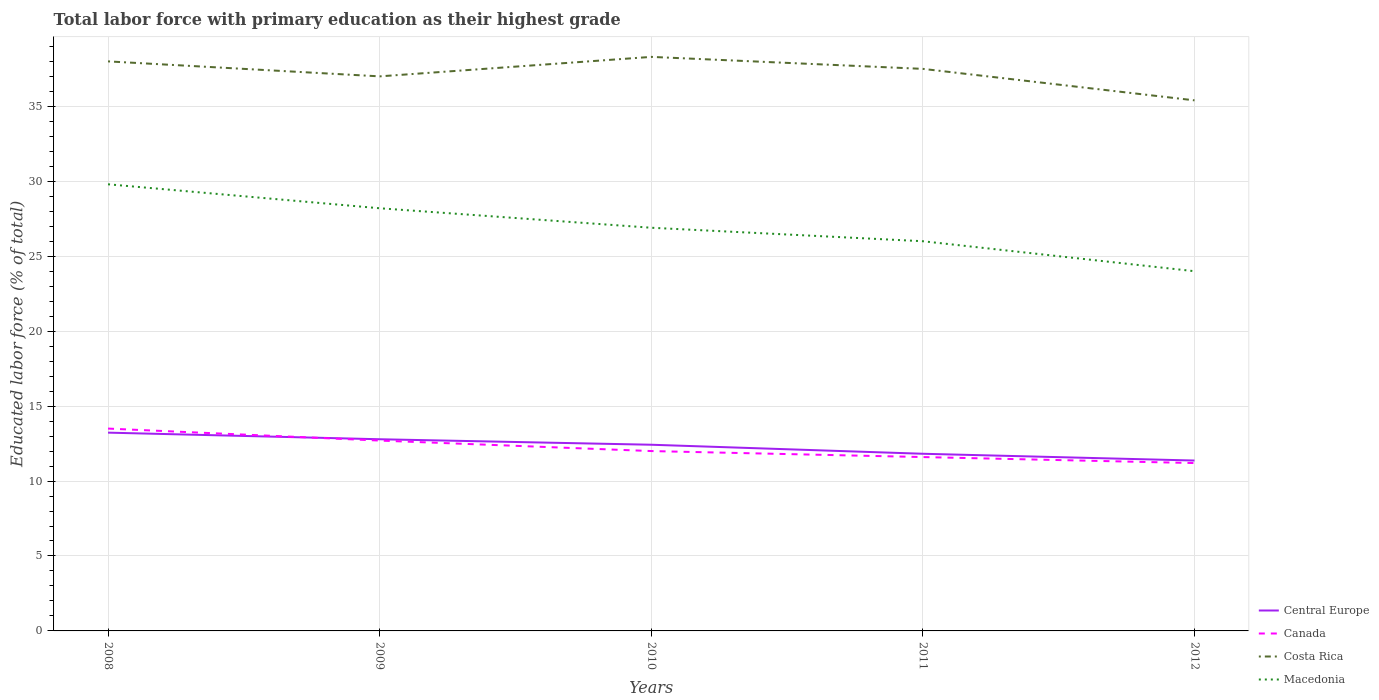How many different coloured lines are there?
Offer a terse response. 4. Does the line corresponding to Canada intersect with the line corresponding to Macedonia?
Make the answer very short. No. Across all years, what is the maximum percentage of total labor force with primary education in Canada?
Your answer should be very brief. 11.2. What is the total percentage of total labor force with primary education in Canada in the graph?
Give a very brief answer. 1.1. What is the difference between the highest and the second highest percentage of total labor force with primary education in Central Europe?
Provide a succinct answer. 1.86. What is the difference between the highest and the lowest percentage of total labor force with primary education in Macedonia?
Give a very brief answer. 2. What is the difference between two consecutive major ticks on the Y-axis?
Provide a succinct answer. 5. Are the values on the major ticks of Y-axis written in scientific E-notation?
Provide a short and direct response. No. Where does the legend appear in the graph?
Make the answer very short. Bottom right. How many legend labels are there?
Provide a short and direct response. 4. How are the legend labels stacked?
Keep it short and to the point. Vertical. What is the title of the graph?
Offer a very short reply. Total labor force with primary education as their highest grade. What is the label or title of the X-axis?
Offer a very short reply. Years. What is the label or title of the Y-axis?
Your answer should be compact. Educated labor force (% of total). What is the Educated labor force (% of total) in Central Europe in 2008?
Provide a short and direct response. 13.23. What is the Educated labor force (% of total) of Macedonia in 2008?
Offer a very short reply. 29.8. What is the Educated labor force (% of total) of Central Europe in 2009?
Make the answer very short. 12.79. What is the Educated labor force (% of total) in Canada in 2009?
Keep it short and to the point. 12.7. What is the Educated labor force (% of total) in Macedonia in 2009?
Give a very brief answer. 28.2. What is the Educated labor force (% of total) in Central Europe in 2010?
Make the answer very short. 12.42. What is the Educated labor force (% of total) of Costa Rica in 2010?
Your answer should be compact. 38.3. What is the Educated labor force (% of total) in Macedonia in 2010?
Offer a very short reply. 26.9. What is the Educated labor force (% of total) of Central Europe in 2011?
Make the answer very short. 11.82. What is the Educated labor force (% of total) of Canada in 2011?
Your answer should be very brief. 11.6. What is the Educated labor force (% of total) in Costa Rica in 2011?
Your answer should be compact. 37.5. What is the Educated labor force (% of total) in Central Europe in 2012?
Provide a short and direct response. 11.37. What is the Educated labor force (% of total) in Canada in 2012?
Your response must be concise. 11.2. What is the Educated labor force (% of total) of Costa Rica in 2012?
Give a very brief answer. 35.4. Across all years, what is the maximum Educated labor force (% of total) of Central Europe?
Provide a short and direct response. 13.23. Across all years, what is the maximum Educated labor force (% of total) in Costa Rica?
Provide a short and direct response. 38.3. Across all years, what is the maximum Educated labor force (% of total) in Macedonia?
Provide a short and direct response. 29.8. Across all years, what is the minimum Educated labor force (% of total) in Central Europe?
Provide a succinct answer. 11.37. Across all years, what is the minimum Educated labor force (% of total) in Canada?
Provide a succinct answer. 11.2. Across all years, what is the minimum Educated labor force (% of total) of Costa Rica?
Give a very brief answer. 35.4. Across all years, what is the minimum Educated labor force (% of total) of Macedonia?
Your response must be concise. 24. What is the total Educated labor force (% of total) of Central Europe in the graph?
Your answer should be very brief. 61.63. What is the total Educated labor force (% of total) of Costa Rica in the graph?
Provide a succinct answer. 186.2. What is the total Educated labor force (% of total) of Macedonia in the graph?
Keep it short and to the point. 134.9. What is the difference between the Educated labor force (% of total) in Central Europe in 2008 and that in 2009?
Your response must be concise. 0.44. What is the difference between the Educated labor force (% of total) of Canada in 2008 and that in 2009?
Offer a terse response. 0.8. What is the difference between the Educated labor force (% of total) in Macedonia in 2008 and that in 2009?
Your answer should be compact. 1.6. What is the difference between the Educated labor force (% of total) in Central Europe in 2008 and that in 2010?
Offer a very short reply. 0.81. What is the difference between the Educated labor force (% of total) of Canada in 2008 and that in 2010?
Your answer should be compact. 1.5. What is the difference between the Educated labor force (% of total) of Macedonia in 2008 and that in 2010?
Your response must be concise. 2.9. What is the difference between the Educated labor force (% of total) of Central Europe in 2008 and that in 2011?
Give a very brief answer. 1.41. What is the difference between the Educated labor force (% of total) in Costa Rica in 2008 and that in 2011?
Offer a terse response. 0.5. What is the difference between the Educated labor force (% of total) in Central Europe in 2008 and that in 2012?
Your answer should be very brief. 1.86. What is the difference between the Educated labor force (% of total) of Canada in 2008 and that in 2012?
Give a very brief answer. 2.3. What is the difference between the Educated labor force (% of total) in Costa Rica in 2008 and that in 2012?
Your answer should be very brief. 2.6. What is the difference between the Educated labor force (% of total) of Central Europe in 2009 and that in 2010?
Your answer should be very brief. 0.37. What is the difference between the Educated labor force (% of total) in Macedonia in 2009 and that in 2010?
Offer a terse response. 1.3. What is the difference between the Educated labor force (% of total) in Central Europe in 2009 and that in 2011?
Provide a succinct answer. 0.97. What is the difference between the Educated labor force (% of total) in Canada in 2009 and that in 2011?
Make the answer very short. 1.1. What is the difference between the Educated labor force (% of total) of Central Europe in 2009 and that in 2012?
Ensure brevity in your answer.  1.42. What is the difference between the Educated labor force (% of total) in Canada in 2009 and that in 2012?
Your answer should be very brief. 1.5. What is the difference between the Educated labor force (% of total) of Costa Rica in 2009 and that in 2012?
Give a very brief answer. 1.6. What is the difference between the Educated labor force (% of total) in Macedonia in 2009 and that in 2012?
Provide a short and direct response. 4.2. What is the difference between the Educated labor force (% of total) in Central Europe in 2010 and that in 2011?
Keep it short and to the point. 0.6. What is the difference between the Educated labor force (% of total) in Costa Rica in 2010 and that in 2011?
Offer a very short reply. 0.8. What is the difference between the Educated labor force (% of total) in Central Europe in 2010 and that in 2012?
Keep it short and to the point. 1.05. What is the difference between the Educated labor force (% of total) of Canada in 2010 and that in 2012?
Offer a terse response. 0.8. What is the difference between the Educated labor force (% of total) in Macedonia in 2010 and that in 2012?
Make the answer very short. 2.9. What is the difference between the Educated labor force (% of total) in Central Europe in 2011 and that in 2012?
Your response must be concise. 0.45. What is the difference between the Educated labor force (% of total) in Canada in 2011 and that in 2012?
Your answer should be compact. 0.4. What is the difference between the Educated labor force (% of total) in Central Europe in 2008 and the Educated labor force (% of total) in Canada in 2009?
Give a very brief answer. 0.53. What is the difference between the Educated labor force (% of total) in Central Europe in 2008 and the Educated labor force (% of total) in Costa Rica in 2009?
Your response must be concise. -23.77. What is the difference between the Educated labor force (% of total) in Central Europe in 2008 and the Educated labor force (% of total) in Macedonia in 2009?
Your answer should be compact. -14.97. What is the difference between the Educated labor force (% of total) of Canada in 2008 and the Educated labor force (% of total) of Costa Rica in 2009?
Ensure brevity in your answer.  -23.5. What is the difference between the Educated labor force (% of total) in Canada in 2008 and the Educated labor force (% of total) in Macedonia in 2009?
Your answer should be compact. -14.7. What is the difference between the Educated labor force (% of total) in Costa Rica in 2008 and the Educated labor force (% of total) in Macedonia in 2009?
Your response must be concise. 9.8. What is the difference between the Educated labor force (% of total) of Central Europe in 2008 and the Educated labor force (% of total) of Canada in 2010?
Offer a terse response. 1.23. What is the difference between the Educated labor force (% of total) in Central Europe in 2008 and the Educated labor force (% of total) in Costa Rica in 2010?
Your answer should be very brief. -25.07. What is the difference between the Educated labor force (% of total) of Central Europe in 2008 and the Educated labor force (% of total) of Macedonia in 2010?
Offer a very short reply. -13.67. What is the difference between the Educated labor force (% of total) of Canada in 2008 and the Educated labor force (% of total) of Costa Rica in 2010?
Your answer should be compact. -24.8. What is the difference between the Educated labor force (% of total) of Costa Rica in 2008 and the Educated labor force (% of total) of Macedonia in 2010?
Your answer should be very brief. 11.1. What is the difference between the Educated labor force (% of total) of Central Europe in 2008 and the Educated labor force (% of total) of Canada in 2011?
Your answer should be compact. 1.63. What is the difference between the Educated labor force (% of total) of Central Europe in 2008 and the Educated labor force (% of total) of Costa Rica in 2011?
Ensure brevity in your answer.  -24.27. What is the difference between the Educated labor force (% of total) of Central Europe in 2008 and the Educated labor force (% of total) of Macedonia in 2011?
Provide a succinct answer. -12.77. What is the difference between the Educated labor force (% of total) in Canada in 2008 and the Educated labor force (% of total) in Costa Rica in 2011?
Ensure brevity in your answer.  -24. What is the difference between the Educated labor force (% of total) of Canada in 2008 and the Educated labor force (% of total) of Macedonia in 2011?
Make the answer very short. -12.5. What is the difference between the Educated labor force (% of total) in Central Europe in 2008 and the Educated labor force (% of total) in Canada in 2012?
Provide a succinct answer. 2.03. What is the difference between the Educated labor force (% of total) in Central Europe in 2008 and the Educated labor force (% of total) in Costa Rica in 2012?
Your answer should be compact. -22.17. What is the difference between the Educated labor force (% of total) in Central Europe in 2008 and the Educated labor force (% of total) in Macedonia in 2012?
Ensure brevity in your answer.  -10.77. What is the difference between the Educated labor force (% of total) in Canada in 2008 and the Educated labor force (% of total) in Costa Rica in 2012?
Make the answer very short. -21.9. What is the difference between the Educated labor force (% of total) in Canada in 2008 and the Educated labor force (% of total) in Macedonia in 2012?
Make the answer very short. -10.5. What is the difference between the Educated labor force (% of total) of Central Europe in 2009 and the Educated labor force (% of total) of Canada in 2010?
Provide a short and direct response. 0.79. What is the difference between the Educated labor force (% of total) in Central Europe in 2009 and the Educated labor force (% of total) in Costa Rica in 2010?
Your answer should be compact. -25.51. What is the difference between the Educated labor force (% of total) in Central Europe in 2009 and the Educated labor force (% of total) in Macedonia in 2010?
Provide a short and direct response. -14.11. What is the difference between the Educated labor force (% of total) in Canada in 2009 and the Educated labor force (% of total) in Costa Rica in 2010?
Provide a succinct answer. -25.6. What is the difference between the Educated labor force (% of total) in Central Europe in 2009 and the Educated labor force (% of total) in Canada in 2011?
Your answer should be compact. 1.19. What is the difference between the Educated labor force (% of total) in Central Europe in 2009 and the Educated labor force (% of total) in Costa Rica in 2011?
Keep it short and to the point. -24.71. What is the difference between the Educated labor force (% of total) in Central Europe in 2009 and the Educated labor force (% of total) in Macedonia in 2011?
Provide a short and direct response. -13.21. What is the difference between the Educated labor force (% of total) in Canada in 2009 and the Educated labor force (% of total) in Costa Rica in 2011?
Offer a terse response. -24.8. What is the difference between the Educated labor force (% of total) of Central Europe in 2009 and the Educated labor force (% of total) of Canada in 2012?
Your answer should be very brief. 1.59. What is the difference between the Educated labor force (% of total) in Central Europe in 2009 and the Educated labor force (% of total) in Costa Rica in 2012?
Provide a short and direct response. -22.61. What is the difference between the Educated labor force (% of total) in Central Europe in 2009 and the Educated labor force (% of total) in Macedonia in 2012?
Provide a short and direct response. -11.21. What is the difference between the Educated labor force (% of total) in Canada in 2009 and the Educated labor force (% of total) in Costa Rica in 2012?
Your response must be concise. -22.7. What is the difference between the Educated labor force (% of total) in Canada in 2009 and the Educated labor force (% of total) in Macedonia in 2012?
Your answer should be very brief. -11.3. What is the difference between the Educated labor force (% of total) of Costa Rica in 2009 and the Educated labor force (% of total) of Macedonia in 2012?
Your answer should be very brief. 13. What is the difference between the Educated labor force (% of total) in Central Europe in 2010 and the Educated labor force (% of total) in Canada in 2011?
Ensure brevity in your answer.  0.82. What is the difference between the Educated labor force (% of total) of Central Europe in 2010 and the Educated labor force (% of total) of Costa Rica in 2011?
Your answer should be very brief. -25.08. What is the difference between the Educated labor force (% of total) in Central Europe in 2010 and the Educated labor force (% of total) in Macedonia in 2011?
Offer a terse response. -13.58. What is the difference between the Educated labor force (% of total) in Canada in 2010 and the Educated labor force (% of total) in Costa Rica in 2011?
Your response must be concise. -25.5. What is the difference between the Educated labor force (% of total) in Canada in 2010 and the Educated labor force (% of total) in Macedonia in 2011?
Keep it short and to the point. -14. What is the difference between the Educated labor force (% of total) in Costa Rica in 2010 and the Educated labor force (% of total) in Macedonia in 2011?
Make the answer very short. 12.3. What is the difference between the Educated labor force (% of total) in Central Europe in 2010 and the Educated labor force (% of total) in Canada in 2012?
Provide a short and direct response. 1.22. What is the difference between the Educated labor force (% of total) of Central Europe in 2010 and the Educated labor force (% of total) of Costa Rica in 2012?
Give a very brief answer. -22.98. What is the difference between the Educated labor force (% of total) of Central Europe in 2010 and the Educated labor force (% of total) of Macedonia in 2012?
Your response must be concise. -11.58. What is the difference between the Educated labor force (% of total) in Canada in 2010 and the Educated labor force (% of total) in Costa Rica in 2012?
Offer a very short reply. -23.4. What is the difference between the Educated labor force (% of total) in Costa Rica in 2010 and the Educated labor force (% of total) in Macedonia in 2012?
Your answer should be very brief. 14.3. What is the difference between the Educated labor force (% of total) of Central Europe in 2011 and the Educated labor force (% of total) of Canada in 2012?
Make the answer very short. 0.62. What is the difference between the Educated labor force (% of total) in Central Europe in 2011 and the Educated labor force (% of total) in Costa Rica in 2012?
Your answer should be compact. -23.58. What is the difference between the Educated labor force (% of total) in Central Europe in 2011 and the Educated labor force (% of total) in Macedonia in 2012?
Keep it short and to the point. -12.18. What is the difference between the Educated labor force (% of total) of Canada in 2011 and the Educated labor force (% of total) of Costa Rica in 2012?
Ensure brevity in your answer.  -23.8. What is the difference between the Educated labor force (% of total) of Canada in 2011 and the Educated labor force (% of total) of Macedonia in 2012?
Make the answer very short. -12.4. What is the average Educated labor force (% of total) in Central Europe per year?
Your answer should be compact. 12.33. What is the average Educated labor force (% of total) of Canada per year?
Offer a terse response. 12.2. What is the average Educated labor force (% of total) in Costa Rica per year?
Your answer should be very brief. 37.24. What is the average Educated labor force (% of total) of Macedonia per year?
Give a very brief answer. 26.98. In the year 2008, what is the difference between the Educated labor force (% of total) in Central Europe and Educated labor force (% of total) in Canada?
Provide a short and direct response. -0.27. In the year 2008, what is the difference between the Educated labor force (% of total) in Central Europe and Educated labor force (% of total) in Costa Rica?
Keep it short and to the point. -24.77. In the year 2008, what is the difference between the Educated labor force (% of total) of Central Europe and Educated labor force (% of total) of Macedonia?
Offer a very short reply. -16.57. In the year 2008, what is the difference between the Educated labor force (% of total) in Canada and Educated labor force (% of total) in Costa Rica?
Offer a terse response. -24.5. In the year 2008, what is the difference between the Educated labor force (% of total) in Canada and Educated labor force (% of total) in Macedonia?
Give a very brief answer. -16.3. In the year 2009, what is the difference between the Educated labor force (% of total) of Central Europe and Educated labor force (% of total) of Canada?
Your answer should be very brief. 0.09. In the year 2009, what is the difference between the Educated labor force (% of total) in Central Europe and Educated labor force (% of total) in Costa Rica?
Provide a short and direct response. -24.21. In the year 2009, what is the difference between the Educated labor force (% of total) in Central Europe and Educated labor force (% of total) in Macedonia?
Offer a terse response. -15.41. In the year 2009, what is the difference between the Educated labor force (% of total) of Canada and Educated labor force (% of total) of Costa Rica?
Your response must be concise. -24.3. In the year 2009, what is the difference between the Educated labor force (% of total) in Canada and Educated labor force (% of total) in Macedonia?
Your response must be concise. -15.5. In the year 2010, what is the difference between the Educated labor force (% of total) of Central Europe and Educated labor force (% of total) of Canada?
Your answer should be very brief. 0.42. In the year 2010, what is the difference between the Educated labor force (% of total) of Central Europe and Educated labor force (% of total) of Costa Rica?
Give a very brief answer. -25.88. In the year 2010, what is the difference between the Educated labor force (% of total) in Central Europe and Educated labor force (% of total) in Macedonia?
Keep it short and to the point. -14.48. In the year 2010, what is the difference between the Educated labor force (% of total) of Canada and Educated labor force (% of total) of Costa Rica?
Provide a short and direct response. -26.3. In the year 2010, what is the difference between the Educated labor force (% of total) of Canada and Educated labor force (% of total) of Macedonia?
Your response must be concise. -14.9. In the year 2011, what is the difference between the Educated labor force (% of total) in Central Europe and Educated labor force (% of total) in Canada?
Your response must be concise. 0.22. In the year 2011, what is the difference between the Educated labor force (% of total) of Central Europe and Educated labor force (% of total) of Costa Rica?
Provide a succinct answer. -25.68. In the year 2011, what is the difference between the Educated labor force (% of total) of Central Europe and Educated labor force (% of total) of Macedonia?
Offer a terse response. -14.18. In the year 2011, what is the difference between the Educated labor force (% of total) of Canada and Educated labor force (% of total) of Costa Rica?
Provide a short and direct response. -25.9. In the year 2011, what is the difference between the Educated labor force (% of total) in Canada and Educated labor force (% of total) in Macedonia?
Offer a terse response. -14.4. In the year 2011, what is the difference between the Educated labor force (% of total) of Costa Rica and Educated labor force (% of total) of Macedonia?
Offer a terse response. 11.5. In the year 2012, what is the difference between the Educated labor force (% of total) in Central Europe and Educated labor force (% of total) in Canada?
Provide a succinct answer. 0.17. In the year 2012, what is the difference between the Educated labor force (% of total) of Central Europe and Educated labor force (% of total) of Costa Rica?
Provide a succinct answer. -24.03. In the year 2012, what is the difference between the Educated labor force (% of total) of Central Europe and Educated labor force (% of total) of Macedonia?
Ensure brevity in your answer.  -12.63. In the year 2012, what is the difference between the Educated labor force (% of total) in Canada and Educated labor force (% of total) in Costa Rica?
Provide a short and direct response. -24.2. What is the ratio of the Educated labor force (% of total) in Central Europe in 2008 to that in 2009?
Your response must be concise. 1.03. What is the ratio of the Educated labor force (% of total) in Canada in 2008 to that in 2009?
Your response must be concise. 1.06. What is the ratio of the Educated labor force (% of total) of Macedonia in 2008 to that in 2009?
Offer a terse response. 1.06. What is the ratio of the Educated labor force (% of total) in Central Europe in 2008 to that in 2010?
Offer a very short reply. 1.06. What is the ratio of the Educated labor force (% of total) in Macedonia in 2008 to that in 2010?
Your answer should be compact. 1.11. What is the ratio of the Educated labor force (% of total) of Central Europe in 2008 to that in 2011?
Offer a very short reply. 1.12. What is the ratio of the Educated labor force (% of total) in Canada in 2008 to that in 2011?
Your answer should be compact. 1.16. What is the ratio of the Educated labor force (% of total) of Costa Rica in 2008 to that in 2011?
Offer a terse response. 1.01. What is the ratio of the Educated labor force (% of total) in Macedonia in 2008 to that in 2011?
Ensure brevity in your answer.  1.15. What is the ratio of the Educated labor force (% of total) in Central Europe in 2008 to that in 2012?
Provide a short and direct response. 1.16. What is the ratio of the Educated labor force (% of total) in Canada in 2008 to that in 2012?
Make the answer very short. 1.21. What is the ratio of the Educated labor force (% of total) in Costa Rica in 2008 to that in 2012?
Make the answer very short. 1.07. What is the ratio of the Educated labor force (% of total) of Macedonia in 2008 to that in 2012?
Provide a succinct answer. 1.24. What is the ratio of the Educated labor force (% of total) of Central Europe in 2009 to that in 2010?
Provide a succinct answer. 1.03. What is the ratio of the Educated labor force (% of total) in Canada in 2009 to that in 2010?
Ensure brevity in your answer.  1.06. What is the ratio of the Educated labor force (% of total) in Costa Rica in 2009 to that in 2010?
Make the answer very short. 0.97. What is the ratio of the Educated labor force (% of total) in Macedonia in 2009 to that in 2010?
Your answer should be compact. 1.05. What is the ratio of the Educated labor force (% of total) in Central Europe in 2009 to that in 2011?
Make the answer very short. 1.08. What is the ratio of the Educated labor force (% of total) of Canada in 2009 to that in 2011?
Your answer should be very brief. 1.09. What is the ratio of the Educated labor force (% of total) of Costa Rica in 2009 to that in 2011?
Your answer should be very brief. 0.99. What is the ratio of the Educated labor force (% of total) in Macedonia in 2009 to that in 2011?
Offer a terse response. 1.08. What is the ratio of the Educated labor force (% of total) in Canada in 2009 to that in 2012?
Provide a short and direct response. 1.13. What is the ratio of the Educated labor force (% of total) in Costa Rica in 2009 to that in 2012?
Provide a succinct answer. 1.05. What is the ratio of the Educated labor force (% of total) of Macedonia in 2009 to that in 2012?
Offer a very short reply. 1.18. What is the ratio of the Educated labor force (% of total) in Central Europe in 2010 to that in 2011?
Make the answer very short. 1.05. What is the ratio of the Educated labor force (% of total) of Canada in 2010 to that in 2011?
Give a very brief answer. 1.03. What is the ratio of the Educated labor force (% of total) in Costa Rica in 2010 to that in 2011?
Ensure brevity in your answer.  1.02. What is the ratio of the Educated labor force (% of total) of Macedonia in 2010 to that in 2011?
Keep it short and to the point. 1.03. What is the ratio of the Educated labor force (% of total) in Central Europe in 2010 to that in 2012?
Provide a short and direct response. 1.09. What is the ratio of the Educated labor force (% of total) in Canada in 2010 to that in 2012?
Offer a very short reply. 1.07. What is the ratio of the Educated labor force (% of total) in Costa Rica in 2010 to that in 2012?
Ensure brevity in your answer.  1.08. What is the ratio of the Educated labor force (% of total) of Macedonia in 2010 to that in 2012?
Provide a short and direct response. 1.12. What is the ratio of the Educated labor force (% of total) in Central Europe in 2011 to that in 2012?
Ensure brevity in your answer.  1.04. What is the ratio of the Educated labor force (% of total) of Canada in 2011 to that in 2012?
Offer a very short reply. 1.04. What is the ratio of the Educated labor force (% of total) of Costa Rica in 2011 to that in 2012?
Offer a very short reply. 1.06. What is the ratio of the Educated labor force (% of total) of Macedonia in 2011 to that in 2012?
Keep it short and to the point. 1.08. What is the difference between the highest and the second highest Educated labor force (% of total) of Central Europe?
Ensure brevity in your answer.  0.44. What is the difference between the highest and the lowest Educated labor force (% of total) in Central Europe?
Ensure brevity in your answer.  1.86. 